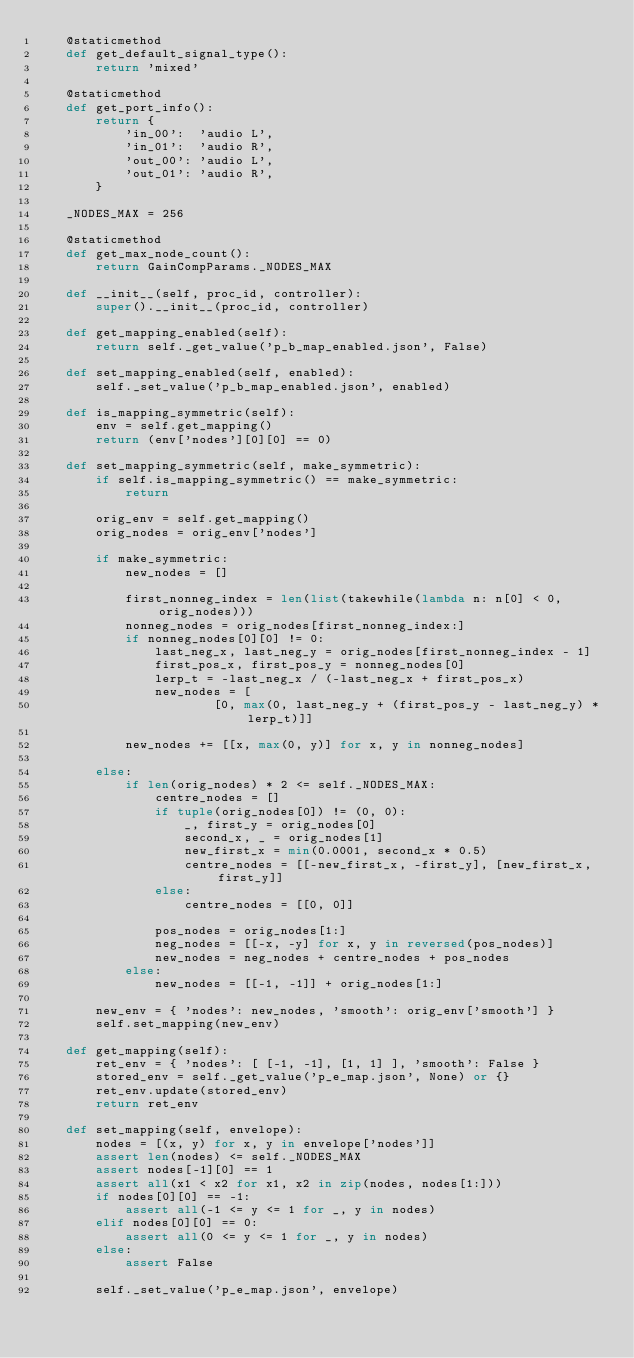<code> <loc_0><loc_0><loc_500><loc_500><_Python_>    @staticmethod
    def get_default_signal_type():
        return 'mixed'

    @staticmethod
    def get_port_info():
        return {
            'in_00':  'audio L',
            'in_01':  'audio R',
            'out_00': 'audio L',
            'out_01': 'audio R',
        }

    _NODES_MAX = 256

    @staticmethod
    def get_max_node_count():
        return GainCompParams._NODES_MAX

    def __init__(self, proc_id, controller):
        super().__init__(proc_id, controller)

    def get_mapping_enabled(self):
        return self._get_value('p_b_map_enabled.json', False)

    def set_mapping_enabled(self, enabled):
        self._set_value('p_b_map_enabled.json', enabled)

    def is_mapping_symmetric(self):
        env = self.get_mapping()
        return (env['nodes'][0][0] == 0)

    def set_mapping_symmetric(self, make_symmetric):
        if self.is_mapping_symmetric() == make_symmetric:
            return

        orig_env = self.get_mapping()
        orig_nodes = orig_env['nodes']

        if make_symmetric:
            new_nodes = []

            first_nonneg_index = len(list(takewhile(lambda n: n[0] < 0, orig_nodes)))
            nonneg_nodes = orig_nodes[first_nonneg_index:]
            if nonneg_nodes[0][0] != 0:
                last_neg_x, last_neg_y = orig_nodes[first_nonneg_index - 1]
                first_pos_x, first_pos_y = nonneg_nodes[0]
                lerp_t = -last_neg_x / (-last_neg_x + first_pos_x)
                new_nodes = [
                        [0, max(0, last_neg_y + (first_pos_y - last_neg_y) * lerp_t)]]

            new_nodes += [[x, max(0, y)] for x, y in nonneg_nodes]

        else:
            if len(orig_nodes) * 2 <= self._NODES_MAX:
                centre_nodes = []
                if tuple(orig_nodes[0]) != (0, 0):
                    _, first_y = orig_nodes[0]
                    second_x, _ = orig_nodes[1]
                    new_first_x = min(0.0001, second_x * 0.5)
                    centre_nodes = [[-new_first_x, -first_y], [new_first_x, first_y]]
                else:
                    centre_nodes = [[0, 0]]

                pos_nodes = orig_nodes[1:]
                neg_nodes = [[-x, -y] for x, y in reversed(pos_nodes)]
                new_nodes = neg_nodes + centre_nodes + pos_nodes
            else:
                new_nodes = [[-1, -1]] + orig_nodes[1:]

        new_env = { 'nodes': new_nodes, 'smooth': orig_env['smooth'] }
        self.set_mapping(new_env)

    def get_mapping(self):
        ret_env = { 'nodes': [ [-1, -1], [1, 1] ], 'smooth': False }
        stored_env = self._get_value('p_e_map.json', None) or {}
        ret_env.update(stored_env)
        return ret_env

    def set_mapping(self, envelope):
        nodes = [(x, y) for x, y in envelope['nodes']]
        assert len(nodes) <= self._NODES_MAX
        assert nodes[-1][0] == 1
        assert all(x1 < x2 for x1, x2 in zip(nodes, nodes[1:]))
        if nodes[0][0] == -1:
            assert all(-1 <= y <= 1 for _, y in nodes)
        elif nodes[0][0] == 0:
            assert all(0 <= y <= 1 for _, y in nodes)
        else:
            assert False

        self._set_value('p_e_map.json', envelope)


</code> 